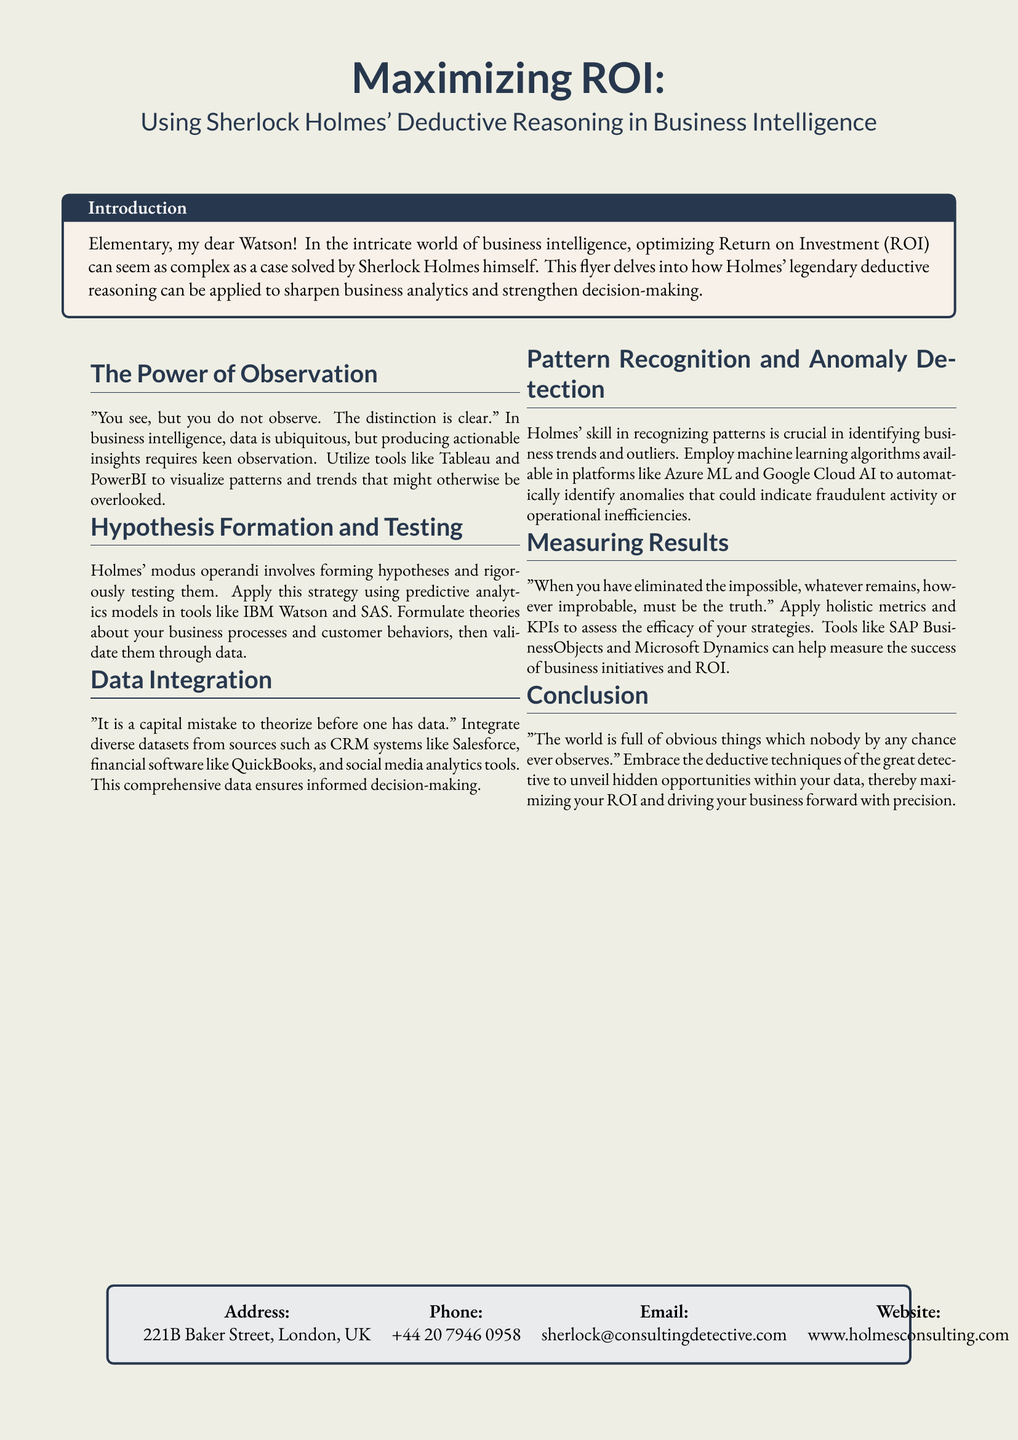What is the title of the flyer? The title is prominently displayed at the top of the document and states the main subject of the flyer.
Answer: Maximizing ROI: Using Sherlock Holmes' Deductive Reasoning in Business Intelligence What is the color theme used for the background? The flyer uses a specific color defined in the document, creating a warm and inviting appearance.
Answer: watsoncream Which tools are suggested for data visualization? The document mentions specific tools that can help visualize data effectively.
Answer: Tableau and PowerBI What is the main conclusion drawn in the flyer? The conclusion summarizes the application of Holmes' techniques in maximizing business potential.
Answer: unveil hidden opportunities What does Holmes state about theorizing? This quote emphasizes the importance of having data before forming theories.
Answer: "It is a capital mistake to theorize before one has data." Which metrics are mentioned for measuring results? The document lists types of metrics that help assess business success.
Answer: holistic metrics and KPIs What address is provided for contact? The contact information is key for anyone needing to reach out for services.
Answer: 221B Baker Street, London, UK Which email is listed for inquiries? The email address provided is where potential clients can send communication.
Answer: sherlock@consultingdetective.com 